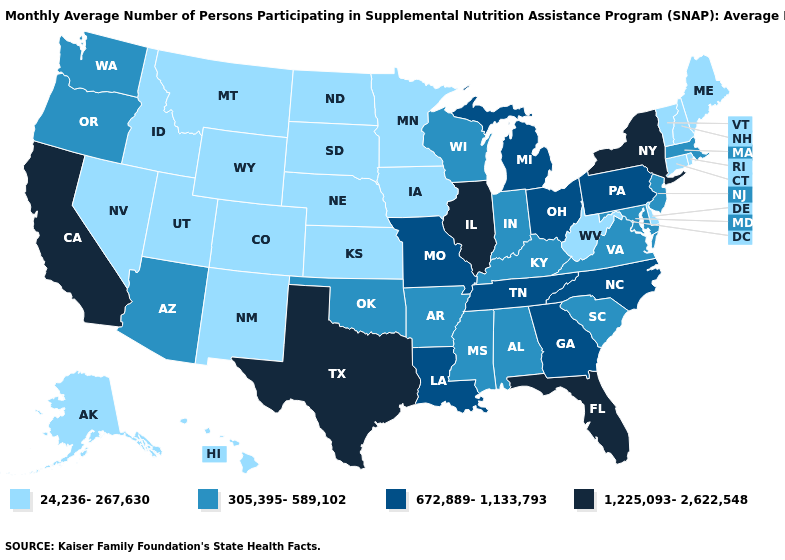What is the highest value in the USA?
Give a very brief answer. 1,225,093-2,622,548. What is the value of Montana?
Write a very short answer. 24,236-267,630. Among the states that border Nebraska , which have the highest value?
Write a very short answer. Missouri. Which states have the lowest value in the USA?
Keep it brief. Alaska, Colorado, Connecticut, Delaware, Hawaii, Idaho, Iowa, Kansas, Maine, Minnesota, Montana, Nebraska, Nevada, New Hampshire, New Mexico, North Dakota, Rhode Island, South Dakota, Utah, Vermont, West Virginia, Wyoming. Name the states that have a value in the range 672,889-1,133,793?
Write a very short answer. Georgia, Louisiana, Michigan, Missouri, North Carolina, Ohio, Pennsylvania, Tennessee. What is the value of Missouri?
Quick response, please. 672,889-1,133,793. Does the map have missing data?
Write a very short answer. No. Among the states that border Nebraska , does Missouri have the highest value?
Quick response, please. Yes. Does Michigan have the lowest value in the USA?
Quick response, please. No. Name the states that have a value in the range 305,395-589,102?
Answer briefly. Alabama, Arizona, Arkansas, Indiana, Kentucky, Maryland, Massachusetts, Mississippi, New Jersey, Oklahoma, Oregon, South Carolina, Virginia, Washington, Wisconsin. Name the states that have a value in the range 1,225,093-2,622,548?
Answer briefly. California, Florida, Illinois, New York, Texas. Which states have the lowest value in the MidWest?
Concise answer only. Iowa, Kansas, Minnesota, Nebraska, North Dakota, South Dakota. Which states hav the highest value in the MidWest?
Be succinct. Illinois. What is the lowest value in states that border Indiana?
Concise answer only. 305,395-589,102. Which states have the lowest value in the South?
Keep it brief. Delaware, West Virginia. 